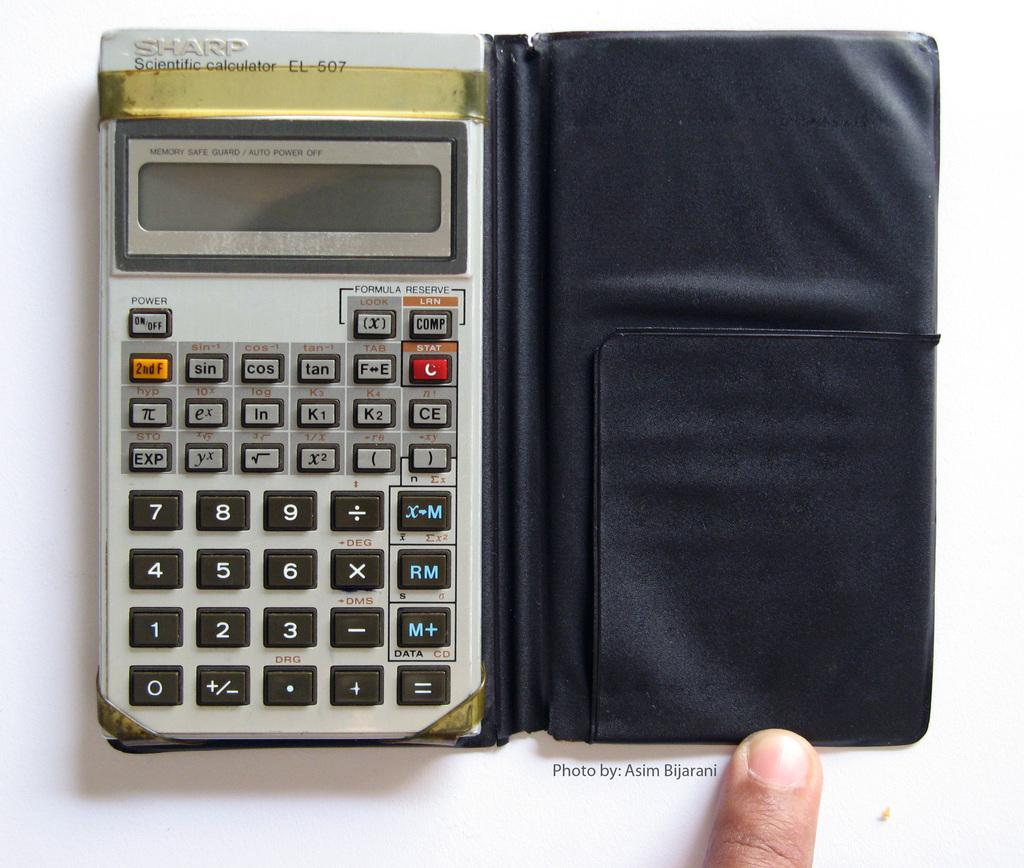<image>
Give a short and clear explanation of the subsequent image. A Sharp Scientific calculator with a man with his finger on it. 